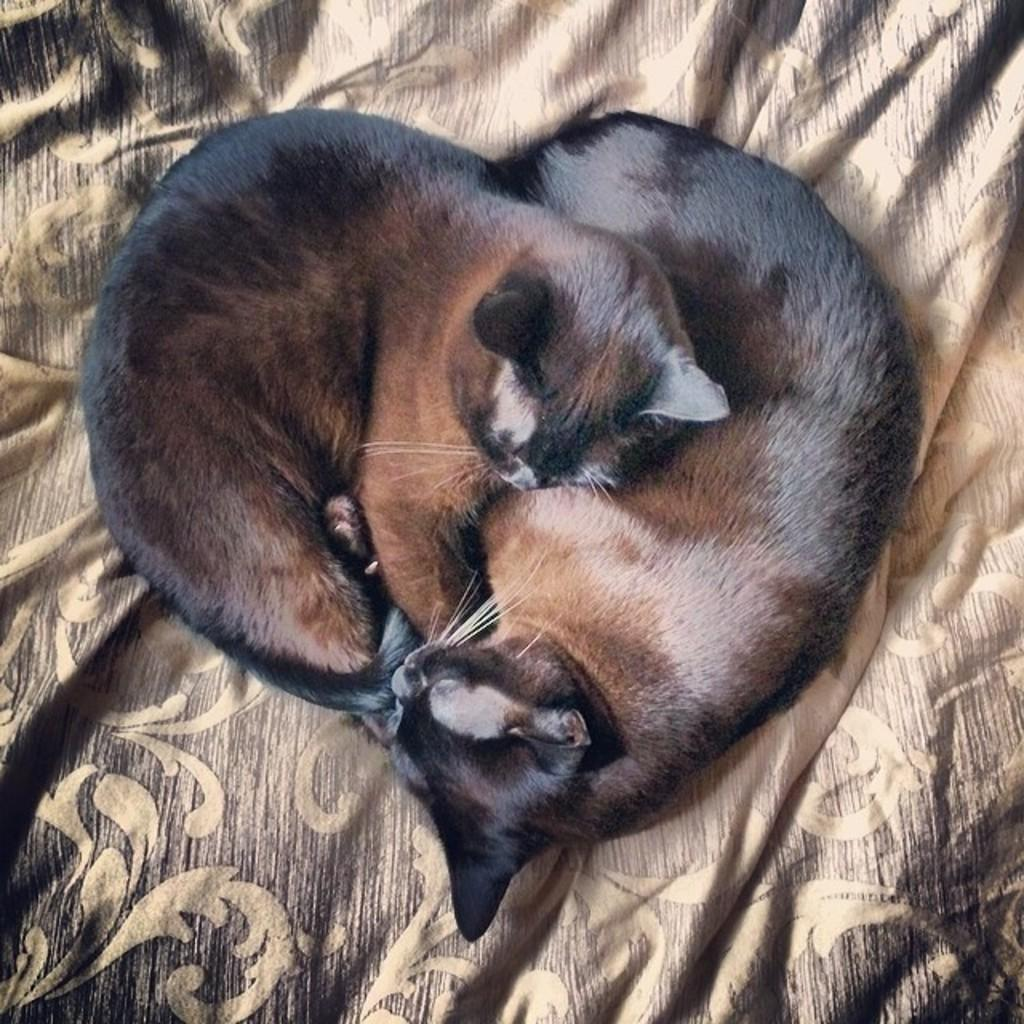How many cats are in the image? There are two cats in the image. What are the cats sitting or lying on? The cats are on a cloth. Are there any icicles hanging from the cats in the image? No, there are no icicles present in the image. What type of locket can be seen around the neck of one of the cats? There is no locket visible around the neck of either cat in the image. 